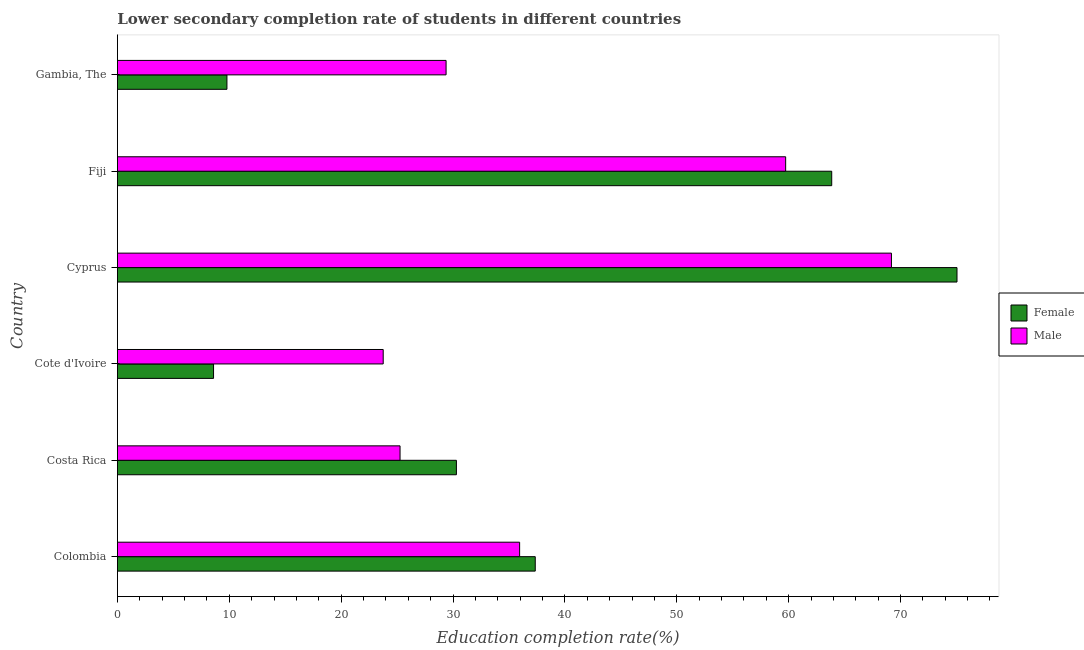Are the number of bars on each tick of the Y-axis equal?
Ensure brevity in your answer.  Yes. How many bars are there on the 4th tick from the bottom?
Ensure brevity in your answer.  2. What is the label of the 4th group of bars from the top?
Your answer should be compact. Cote d'Ivoire. In how many cases, is the number of bars for a given country not equal to the number of legend labels?
Your response must be concise. 0. What is the education completion rate of male students in Colombia?
Provide a succinct answer. 35.96. Across all countries, what is the maximum education completion rate of male students?
Give a very brief answer. 69.19. Across all countries, what is the minimum education completion rate of female students?
Make the answer very short. 8.59. In which country was the education completion rate of male students maximum?
Offer a very short reply. Cyprus. In which country was the education completion rate of female students minimum?
Keep it short and to the point. Cote d'Ivoire. What is the total education completion rate of female students in the graph?
Your answer should be compact. 224.94. What is the difference between the education completion rate of female students in Costa Rica and that in Cyprus?
Provide a succinct answer. -44.75. What is the difference between the education completion rate of female students in Colombia and the education completion rate of male students in Cyprus?
Offer a terse response. -31.84. What is the average education completion rate of female students per country?
Your answer should be very brief. 37.49. What is the difference between the education completion rate of female students and education completion rate of male students in Costa Rica?
Your answer should be compact. 5.04. In how many countries, is the education completion rate of male students greater than 18 %?
Provide a short and direct response. 6. What is the ratio of the education completion rate of female students in Costa Rica to that in Fiji?
Keep it short and to the point. 0.47. Is the education completion rate of male students in Colombia less than that in Fiji?
Keep it short and to the point. Yes. Is the difference between the education completion rate of female students in Colombia and Fiji greater than the difference between the education completion rate of male students in Colombia and Fiji?
Make the answer very short. No. What is the difference between the highest and the second highest education completion rate of female students?
Your response must be concise. 11.2. What is the difference between the highest and the lowest education completion rate of female students?
Offer a very short reply. 66.46. In how many countries, is the education completion rate of female students greater than the average education completion rate of female students taken over all countries?
Ensure brevity in your answer.  2. Is the sum of the education completion rate of male students in Cote d'Ivoire and Fiji greater than the maximum education completion rate of female students across all countries?
Keep it short and to the point. Yes. How many bars are there?
Your answer should be very brief. 12. What is the difference between two consecutive major ticks on the X-axis?
Offer a very short reply. 10. Does the graph contain grids?
Offer a very short reply. No. Where does the legend appear in the graph?
Provide a short and direct response. Center right. How many legend labels are there?
Your answer should be very brief. 2. What is the title of the graph?
Your answer should be compact. Lower secondary completion rate of students in different countries. What is the label or title of the X-axis?
Make the answer very short. Education completion rate(%). What is the label or title of the Y-axis?
Provide a succinct answer. Country. What is the Education completion rate(%) of Female in Colombia?
Make the answer very short. 37.35. What is the Education completion rate(%) in Male in Colombia?
Your response must be concise. 35.96. What is the Education completion rate(%) of Female in Costa Rica?
Provide a short and direct response. 30.3. What is the Education completion rate(%) of Male in Costa Rica?
Ensure brevity in your answer.  25.27. What is the Education completion rate(%) in Female in Cote d'Ivoire?
Your response must be concise. 8.59. What is the Education completion rate(%) in Male in Cote d'Ivoire?
Keep it short and to the point. 23.76. What is the Education completion rate(%) of Female in Cyprus?
Your response must be concise. 75.05. What is the Education completion rate(%) in Male in Cyprus?
Offer a very short reply. 69.19. What is the Education completion rate(%) in Female in Fiji?
Give a very brief answer. 63.85. What is the Education completion rate(%) of Male in Fiji?
Ensure brevity in your answer.  59.73. What is the Education completion rate(%) of Female in Gambia, The?
Provide a short and direct response. 9.79. What is the Education completion rate(%) of Male in Gambia, The?
Offer a terse response. 29.38. Across all countries, what is the maximum Education completion rate(%) of Female?
Provide a short and direct response. 75.05. Across all countries, what is the maximum Education completion rate(%) in Male?
Keep it short and to the point. 69.19. Across all countries, what is the minimum Education completion rate(%) of Female?
Your response must be concise. 8.59. Across all countries, what is the minimum Education completion rate(%) in Male?
Offer a terse response. 23.76. What is the total Education completion rate(%) in Female in the graph?
Offer a very short reply. 224.94. What is the total Education completion rate(%) in Male in the graph?
Provide a succinct answer. 243.29. What is the difference between the Education completion rate(%) in Female in Colombia and that in Costa Rica?
Ensure brevity in your answer.  7.05. What is the difference between the Education completion rate(%) of Male in Colombia and that in Costa Rica?
Your answer should be very brief. 10.69. What is the difference between the Education completion rate(%) in Female in Colombia and that in Cote d'Ivoire?
Keep it short and to the point. 28.76. What is the difference between the Education completion rate(%) in Male in Colombia and that in Cote d'Ivoire?
Ensure brevity in your answer.  12.2. What is the difference between the Education completion rate(%) in Female in Colombia and that in Cyprus?
Make the answer very short. -37.7. What is the difference between the Education completion rate(%) of Male in Colombia and that in Cyprus?
Your answer should be compact. -33.24. What is the difference between the Education completion rate(%) in Female in Colombia and that in Fiji?
Provide a short and direct response. -26.5. What is the difference between the Education completion rate(%) of Male in Colombia and that in Fiji?
Provide a succinct answer. -23.78. What is the difference between the Education completion rate(%) of Female in Colombia and that in Gambia, The?
Offer a terse response. 27.56. What is the difference between the Education completion rate(%) in Male in Colombia and that in Gambia, The?
Offer a terse response. 6.57. What is the difference between the Education completion rate(%) in Female in Costa Rica and that in Cote d'Ivoire?
Offer a terse response. 21.71. What is the difference between the Education completion rate(%) of Male in Costa Rica and that in Cote d'Ivoire?
Provide a short and direct response. 1.51. What is the difference between the Education completion rate(%) in Female in Costa Rica and that in Cyprus?
Make the answer very short. -44.75. What is the difference between the Education completion rate(%) of Male in Costa Rica and that in Cyprus?
Provide a short and direct response. -43.92. What is the difference between the Education completion rate(%) in Female in Costa Rica and that in Fiji?
Keep it short and to the point. -33.55. What is the difference between the Education completion rate(%) in Male in Costa Rica and that in Fiji?
Your answer should be compact. -34.47. What is the difference between the Education completion rate(%) in Female in Costa Rica and that in Gambia, The?
Your answer should be very brief. 20.51. What is the difference between the Education completion rate(%) of Male in Costa Rica and that in Gambia, The?
Ensure brevity in your answer.  -4.12. What is the difference between the Education completion rate(%) in Female in Cote d'Ivoire and that in Cyprus?
Your answer should be very brief. -66.46. What is the difference between the Education completion rate(%) of Male in Cote d'Ivoire and that in Cyprus?
Provide a short and direct response. -45.43. What is the difference between the Education completion rate(%) of Female in Cote d'Ivoire and that in Fiji?
Make the answer very short. -55.26. What is the difference between the Education completion rate(%) in Male in Cote d'Ivoire and that in Fiji?
Your answer should be compact. -35.97. What is the difference between the Education completion rate(%) of Female in Cote d'Ivoire and that in Gambia, The?
Provide a short and direct response. -1.2. What is the difference between the Education completion rate(%) of Male in Cote d'Ivoire and that in Gambia, The?
Give a very brief answer. -5.62. What is the difference between the Education completion rate(%) in Female in Cyprus and that in Fiji?
Give a very brief answer. 11.2. What is the difference between the Education completion rate(%) in Male in Cyprus and that in Fiji?
Keep it short and to the point. 9.46. What is the difference between the Education completion rate(%) in Female in Cyprus and that in Gambia, The?
Give a very brief answer. 65.26. What is the difference between the Education completion rate(%) of Male in Cyprus and that in Gambia, The?
Provide a succinct answer. 39.81. What is the difference between the Education completion rate(%) in Female in Fiji and that in Gambia, The?
Provide a short and direct response. 54.06. What is the difference between the Education completion rate(%) in Male in Fiji and that in Gambia, The?
Your answer should be very brief. 30.35. What is the difference between the Education completion rate(%) of Female in Colombia and the Education completion rate(%) of Male in Costa Rica?
Make the answer very short. 12.09. What is the difference between the Education completion rate(%) of Female in Colombia and the Education completion rate(%) of Male in Cote d'Ivoire?
Keep it short and to the point. 13.59. What is the difference between the Education completion rate(%) of Female in Colombia and the Education completion rate(%) of Male in Cyprus?
Your answer should be very brief. -31.84. What is the difference between the Education completion rate(%) in Female in Colombia and the Education completion rate(%) in Male in Fiji?
Your answer should be very brief. -22.38. What is the difference between the Education completion rate(%) in Female in Colombia and the Education completion rate(%) in Male in Gambia, The?
Your answer should be compact. 7.97. What is the difference between the Education completion rate(%) of Female in Costa Rica and the Education completion rate(%) of Male in Cote d'Ivoire?
Make the answer very short. 6.54. What is the difference between the Education completion rate(%) in Female in Costa Rica and the Education completion rate(%) in Male in Cyprus?
Make the answer very short. -38.89. What is the difference between the Education completion rate(%) of Female in Costa Rica and the Education completion rate(%) of Male in Fiji?
Make the answer very short. -29.43. What is the difference between the Education completion rate(%) in Female in Costa Rica and the Education completion rate(%) in Male in Gambia, The?
Keep it short and to the point. 0.92. What is the difference between the Education completion rate(%) of Female in Cote d'Ivoire and the Education completion rate(%) of Male in Cyprus?
Provide a short and direct response. -60.6. What is the difference between the Education completion rate(%) in Female in Cote d'Ivoire and the Education completion rate(%) in Male in Fiji?
Offer a terse response. -51.14. What is the difference between the Education completion rate(%) in Female in Cote d'Ivoire and the Education completion rate(%) in Male in Gambia, The?
Make the answer very short. -20.79. What is the difference between the Education completion rate(%) in Female in Cyprus and the Education completion rate(%) in Male in Fiji?
Your answer should be compact. 15.32. What is the difference between the Education completion rate(%) in Female in Cyprus and the Education completion rate(%) in Male in Gambia, The?
Provide a succinct answer. 45.67. What is the difference between the Education completion rate(%) in Female in Fiji and the Education completion rate(%) in Male in Gambia, The?
Offer a very short reply. 34.47. What is the average Education completion rate(%) of Female per country?
Make the answer very short. 37.49. What is the average Education completion rate(%) of Male per country?
Offer a very short reply. 40.55. What is the difference between the Education completion rate(%) in Female and Education completion rate(%) in Male in Colombia?
Your answer should be very brief. 1.4. What is the difference between the Education completion rate(%) in Female and Education completion rate(%) in Male in Costa Rica?
Keep it short and to the point. 5.04. What is the difference between the Education completion rate(%) in Female and Education completion rate(%) in Male in Cote d'Ivoire?
Provide a succinct answer. -15.17. What is the difference between the Education completion rate(%) of Female and Education completion rate(%) of Male in Cyprus?
Ensure brevity in your answer.  5.86. What is the difference between the Education completion rate(%) of Female and Education completion rate(%) of Male in Fiji?
Keep it short and to the point. 4.12. What is the difference between the Education completion rate(%) of Female and Education completion rate(%) of Male in Gambia, The?
Keep it short and to the point. -19.59. What is the ratio of the Education completion rate(%) in Female in Colombia to that in Costa Rica?
Your response must be concise. 1.23. What is the ratio of the Education completion rate(%) of Male in Colombia to that in Costa Rica?
Your response must be concise. 1.42. What is the ratio of the Education completion rate(%) of Female in Colombia to that in Cote d'Ivoire?
Your response must be concise. 4.35. What is the ratio of the Education completion rate(%) in Male in Colombia to that in Cote d'Ivoire?
Offer a terse response. 1.51. What is the ratio of the Education completion rate(%) in Female in Colombia to that in Cyprus?
Offer a very short reply. 0.5. What is the ratio of the Education completion rate(%) of Male in Colombia to that in Cyprus?
Make the answer very short. 0.52. What is the ratio of the Education completion rate(%) of Female in Colombia to that in Fiji?
Give a very brief answer. 0.58. What is the ratio of the Education completion rate(%) in Male in Colombia to that in Fiji?
Your answer should be very brief. 0.6. What is the ratio of the Education completion rate(%) in Female in Colombia to that in Gambia, The?
Ensure brevity in your answer.  3.81. What is the ratio of the Education completion rate(%) of Male in Colombia to that in Gambia, The?
Your response must be concise. 1.22. What is the ratio of the Education completion rate(%) of Female in Costa Rica to that in Cote d'Ivoire?
Your answer should be compact. 3.53. What is the ratio of the Education completion rate(%) in Male in Costa Rica to that in Cote d'Ivoire?
Ensure brevity in your answer.  1.06. What is the ratio of the Education completion rate(%) of Female in Costa Rica to that in Cyprus?
Your response must be concise. 0.4. What is the ratio of the Education completion rate(%) in Male in Costa Rica to that in Cyprus?
Ensure brevity in your answer.  0.37. What is the ratio of the Education completion rate(%) in Female in Costa Rica to that in Fiji?
Your response must be concise. 0.47. What is the ratio of the Education completion rate(%) in Male in Costa Rica to that in Fiji?
Your response must be concise. 0.42. What is the ratio of the Education completion rate(%) in Female in Costa Rica to that in Gambia, The?
Keep it short and to the point. 3.09. What is the ratio of the Education completion rate(%) in Male in Costa Rica to that in Gambia, The?
Provide a short and direct response. 0.86. What is the ratio of the Education completion rate(%) in Female in Cote d'Ivoire to that in Cyprus?
Your response must be concise. 0.11. What is the ratio of the Education completion rate(%) of Male in Cote d'Ivoire to that in Cyprus?
Keep it short and to the point. 0.34. What is the ratio of the Education completion rate(%) of Female in Cote d'Ivoire to that in Fiji?
Make the answer very short. 0.13. What is the ratio of the Education completion rate(%) of Male in Cote d'Ivoire to that in Fiji?
Keep it short and to the point. 0.4. What is the ratio of the Education completion rate(%) in Female in Cote d'Ivoire to that in Gambia, The?
Your response must be concise. 0.88. What is the ratio of the Education completion rate(%) in Male in Cote d'Ivoire to that in Gambia, The?
Your answer should be compact. 0.81. What is the ratio of the Education completion rate(%) in Female in Cyprus to that in Fiji?
Provide a short and direct response. 1.18. What is the ratio of the Education completion rate(%) of Male in Cyprus to that in Fiji?
Your response must be concise. 1.16. What is the ratio of the Education completion rate(%) in Female in Cyprus to that in Gambia, The?
Offer a terse response. 7.66. What is the ratio of the Education completion rate(%) of Male in Cyprus to that in Gambia, The?
Make the answer very short. 2.35. What is the ratio of the Education completion rate(%) in Female in Fiji to that in Gambia, The?
Offer a terse response. 6.52. What is the ratio of the Education completion rate(%) in Male in Fiji to that in Gambia, The?
Your answer should be very brief. 2.03. What is the difference between the highest and the second highest Education completion rate(%) of Female?
Provide a succinct answer. 11.2. What is the difference between the highest and the second highest Education completion rate(%) of Male?
Your answer should be compact. 9.46. What is the difference between the highest and the lowest Education completion rate(%) of Female?
Your response must be concise. 66.46. What is the difference between the highest and the lowest Education completion rate(%) of Male?
Your answer should be compact. 45.43. 